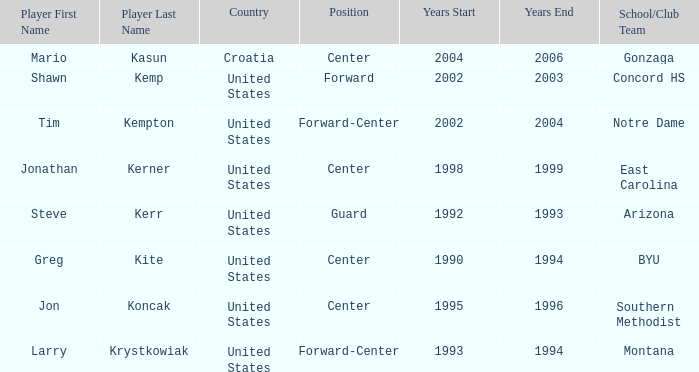Could you parse the entire table as a dict? {'header': ['Player First Name', 'Player Last Name', 'Country', 'Position', 'Years Start', 'Years End', 'School/Club Team'], 'rows': [['Mario', 'Kasun', 'Croatia', 'Center', '2004', '2006', 'Gonzaga'], ['Shawn', 'Kemp', 'United States', 'Forward', '2002', '2003', 'Concord HS'], ['Tim', 'Kempton', 'United States', 'Forward-Center', '2002', '2004', 'Notre Dame'], ['Jonathan', 'Kerner', 'United States', 'Center', '1998', '1999', 'East Carolina'], ['Steve', 'Kerr', 'United States', 'Guard', '1992', '1993', 'Arizona'], ['Greg', 'Kite', 'United States', 'Center', '1990', '1994', 'BYU'], ['Jon', 'Koncak', 'United States', 'Center', '1995', '1996', 'Southern Methodist'], ['Larry', 'Krystkowiak', 'United States', 'Forward-Center', '1993', '1994', 'Montana']]} What nationality has jon koncak as the player? United States. 